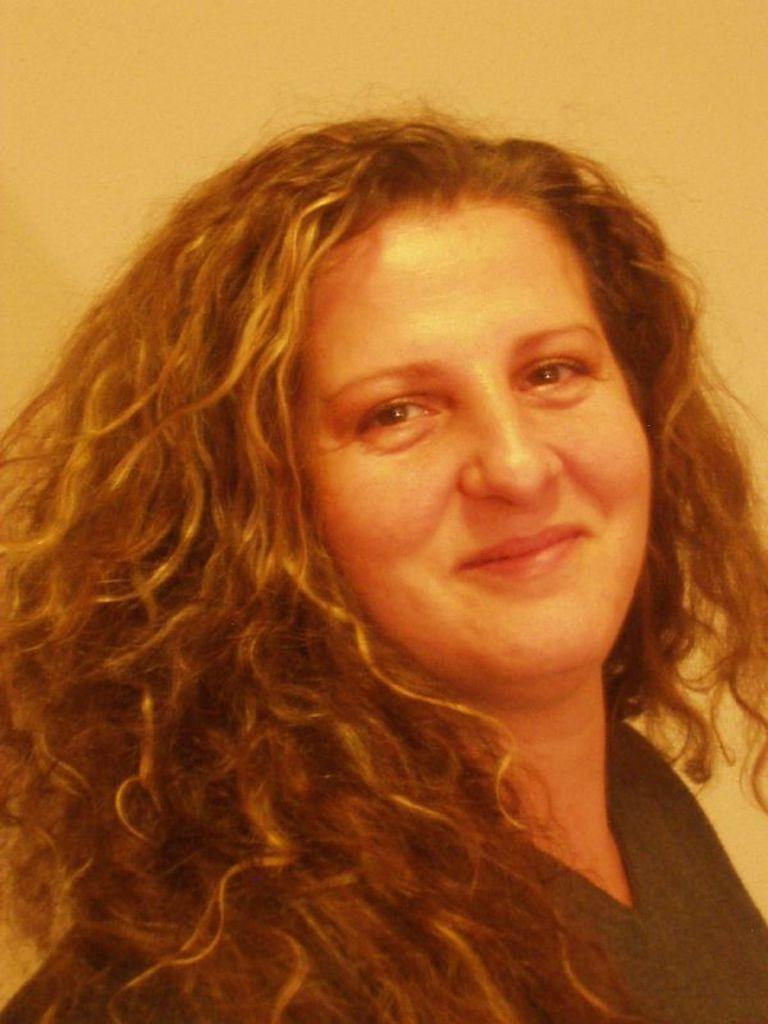Who is the main subject in the image? There is a woman in the image. What expression does the woman have? The woman is smiling. Can you describe the background of the image? The background of the image is plain. What is the woman's example of good governance in the image? There is no reference to governance or any examples in the image, so it's not possible to determine what the woman might be demonstrating in terms of good governance. 